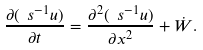<formula> <loc_0><loc_0><loc_500><loc_500>\frac { \partial ( \ s ^ { - 1 } u ) } { \partial t } = \frac { \partial ^ { 2 } ( \ s ^ { - 1 } u ) } { \partial x ^ { 2 } } + \dot { W } .</formula> 